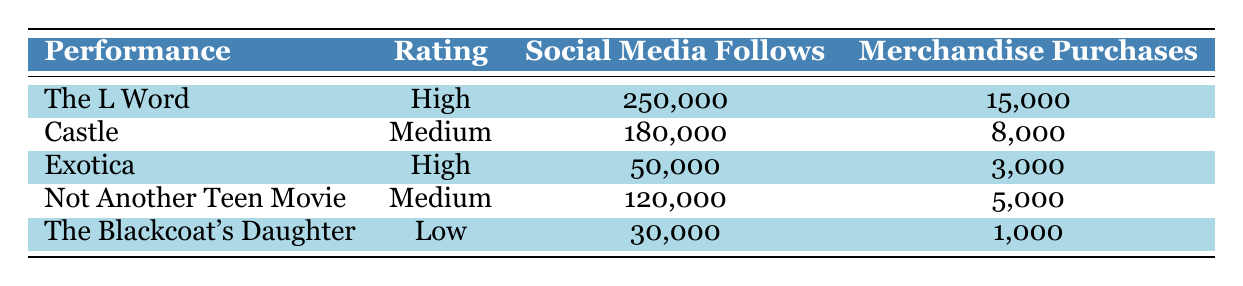What is the highest rating achieved by Mia Kirshner in this table? Looking at the "Rating" column, the highest rating listed is "High." There are two performances, "The L Word" and "Exotica," that achieved this rating.
Answer: High Which performance had the most social media follows? By comparing the "Social Media Follows" numbers, "The L Word" has 250,000 follows, which is the highest among all the performances listed.
Answer: The L Word What is the total number of merchandise purchases for performances rated as Medium? The performances rated as Medium are "Castle" and "Not Another Teen Movie." The total merchandise purchases for these is 8,000 + 5,000 = 13,000.
Answer: 13,000 Is the number of social media follows for "Not Another Teen Movie" greater than that for "The Blackcoat's Daughter"? "Not Another Teen Movie" has 120,000 social media follows, while "The Blackcoat's Daughter" has 30,000. Since 120,000 is greater than 30,000, the statement is true.
Answer: Yes What is the average number of merchandise purchases across all performances? To calculate the average, first sum the merchandise purchases: 15,000 + 8,000 + 3,000 + 5,000 + 1,000 = 32,000. There are 5 performances, so the average is 32,000 divided by 5, which equals 6,400.
Answer: 6,400 Which performance had the least number of merchandise purchases? By examining the "Merchandise Purchases" column, "The Blackcoat's Daughter" with 1,000 purchases is the lowest.
Answer: The Blackcoat's Daughter If we consider performances that received a "High" rating, what is their combined total for social media follows? The performances with a "High" rating are "The L Word" (250,000) and "Exotica" (50,000). Adding these gives 250,000 + 50,000 = 300,000 for the total social media follows.
Answer: 300,000 Are there any performances listed that received a low rating? The table includes "The Blackcoat's Daughter," which has a low rating, confirming the existence of such a performance.
Answer: Yes 